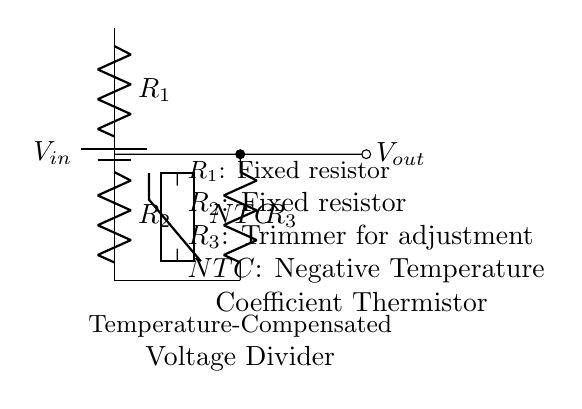What is the input voltage in this circuit? The input voltage, denoted as \( V_{in} \), is provided by the battery connected at the top of the voltage divider circuit.
Answer: \( V_{in} \) How many resistors are present in the circuit? There are three resistors in the circuit: \( R_1 \), \( R_2 \), and \( R_3 \). The total count of resistors is simply the sum of these components.
Answer: 3 What type of thermistor is used in this circuit? The circuit employs a Negative Temperature Coefficient (NTC) thermistor, which is indicated in the diagram next to the component symbol.
Answer: NTC What is the purpose of \( R_3 \) in this configuration? \( R_3 \) is a trimmer resistor used for adjustment, allowing fine-tuning of the output voltage by changing the resistance in the voltage divider.
Answer: Adjustment What happens to the output voltage when the temperature increases? As the temperature increases, the resistance of the NTC thermistor decreases, which will generally result in an increase in output voltage since it alters the voltage division ratio.
Answer: Increases What is the output voltage location in this circuit? The output voltage \( V_{out} \) is located at the node where \( R_2 \) connects to \( R_3 \), indicated by the short line leading to the right of the circuit.
Answer: \( V_{out} \) 